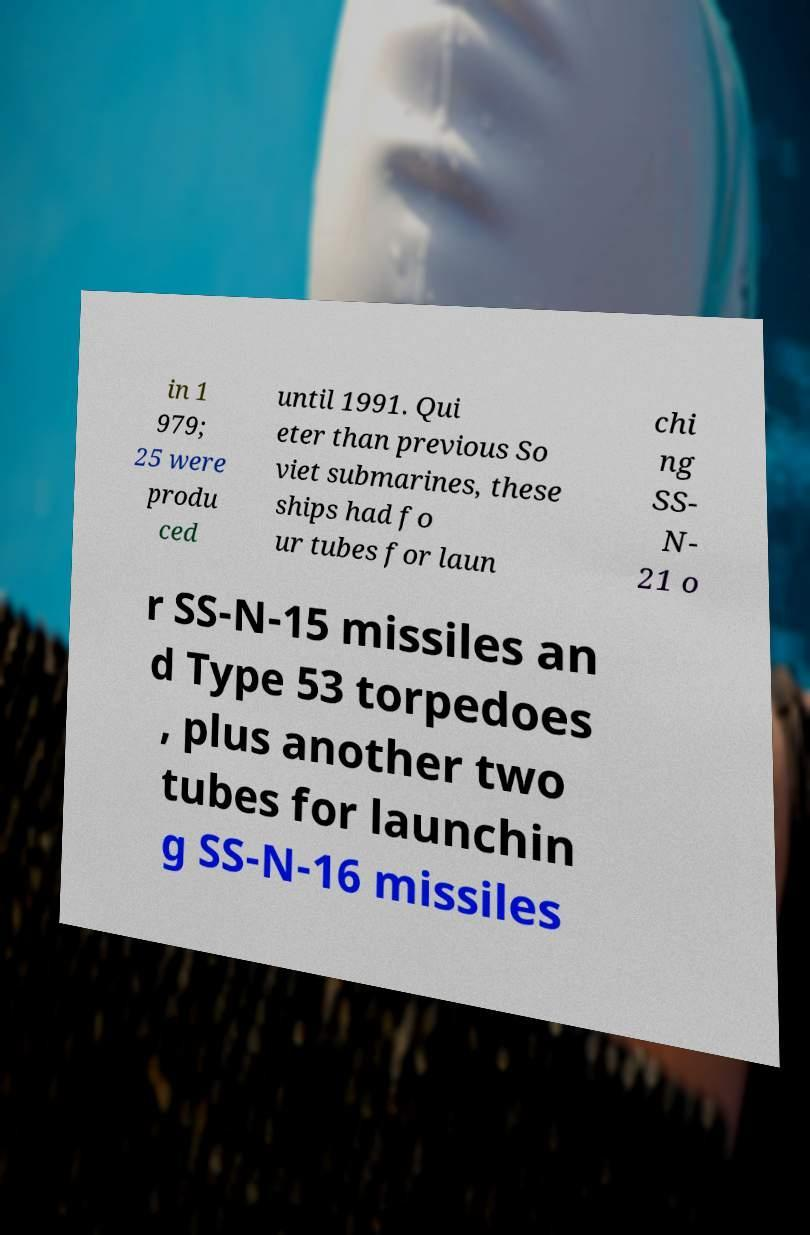For documentation purposes, I need the text within this image transcribed. Could you provide that? in 1 979; 25 were produ ced until 1991. Qui eter than previous So viet submarines, these ships had fo ur tubes for laun chi ng SS- N- 21 o r SS-N-15 missiles an d Type 53 torpedoes , plus another two tubes for launchin g SS-N-16 missiles 